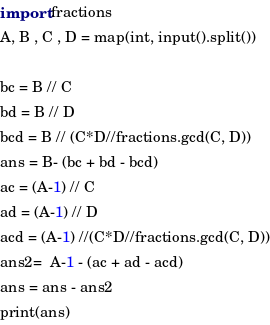<code> <loc_0><loc_0><loc_500><loc_500><_Python_>import fractions
A, B , C , D = map(int, input().split())

bc = B // C 
bd = B // D
bcd = B // (C*D//fractions.gcd(C, D))
ans = B- (bc + bd - bcd)
ac = (A-1) // C
ad = (A-1) // D
acd = (A-1) //(C*D//fractions.gcd(C, D))
ans2=  A-1 - (ac + ad - acd)
ans = ans - ans2
print(ans)</code> 